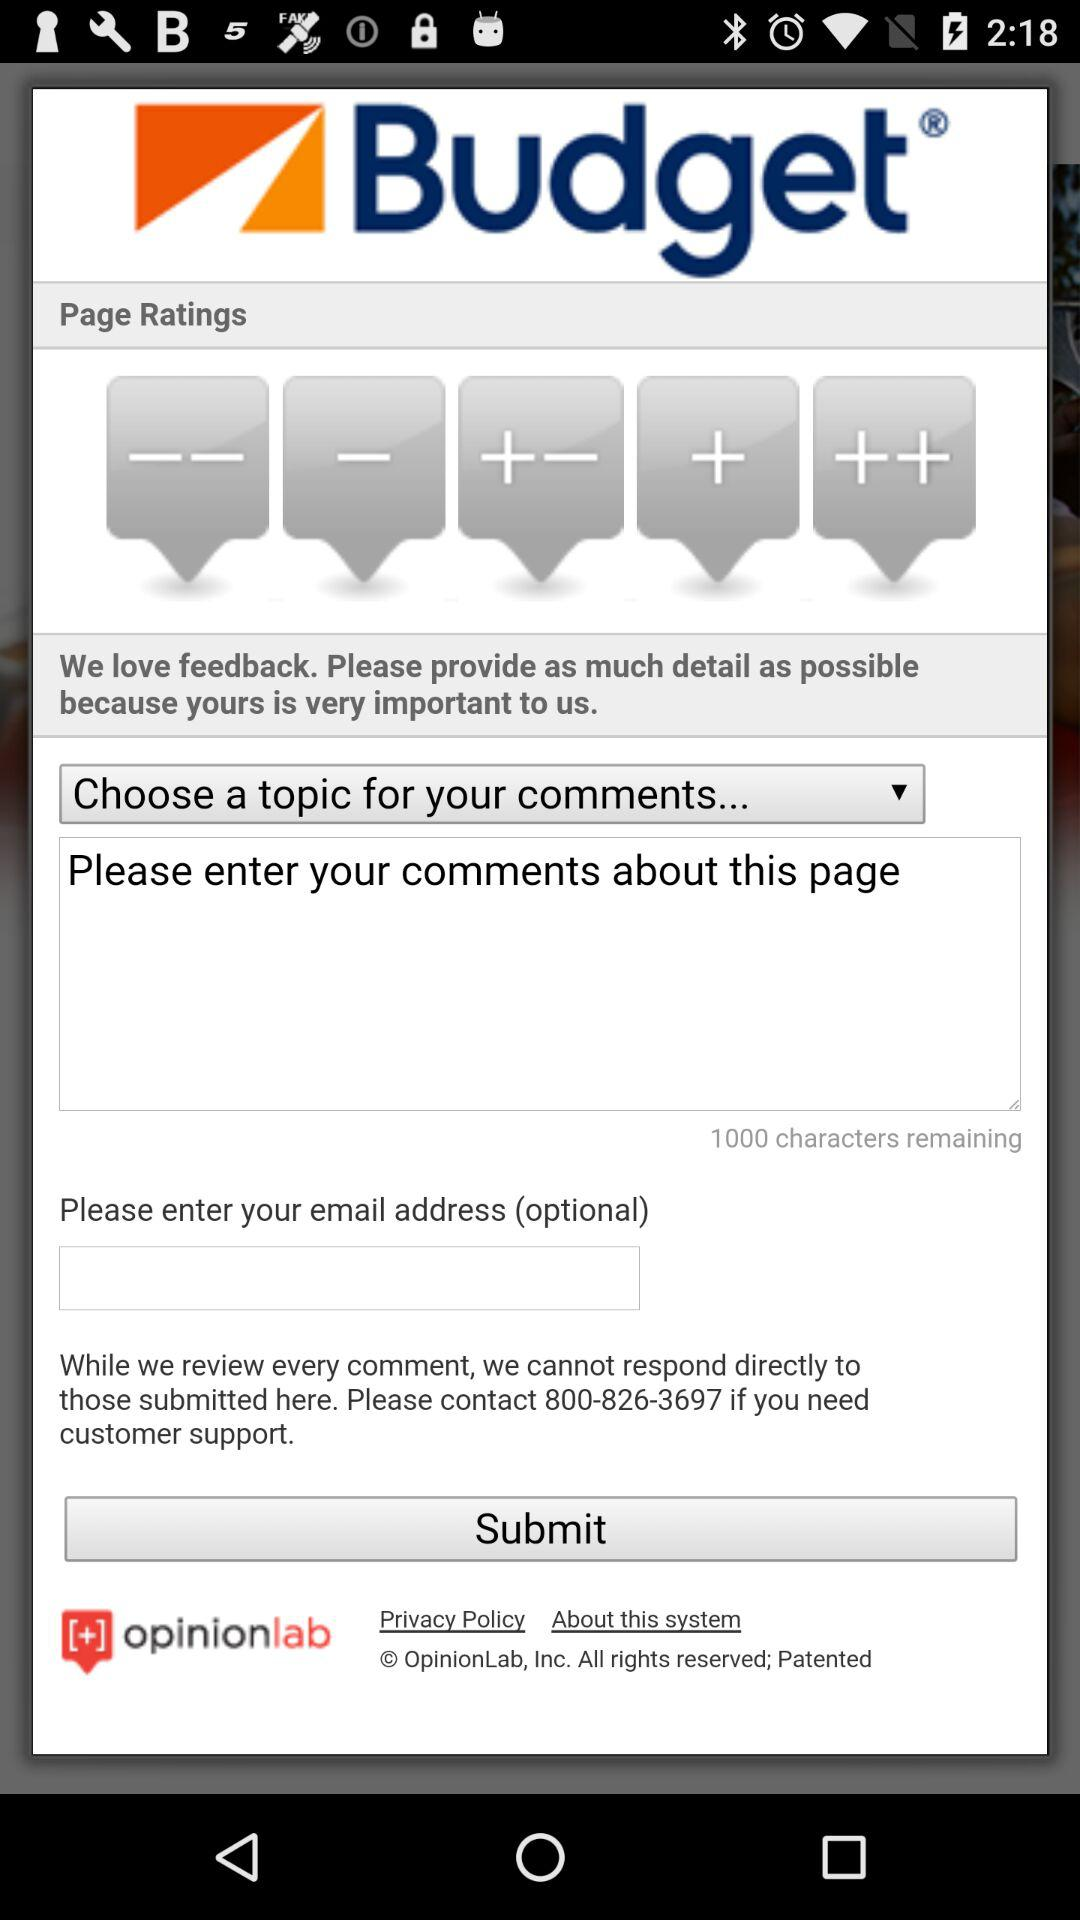How many characters are remaining for the comment? There are 1000 characters remaining for the comment. 